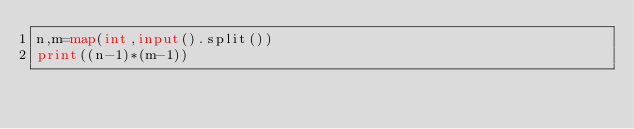<code> <loc_0><loc_0><loc_500><loc_500><_Python_>n,m=map(int,input().split())
print((n-1)*(m-1))</code> 